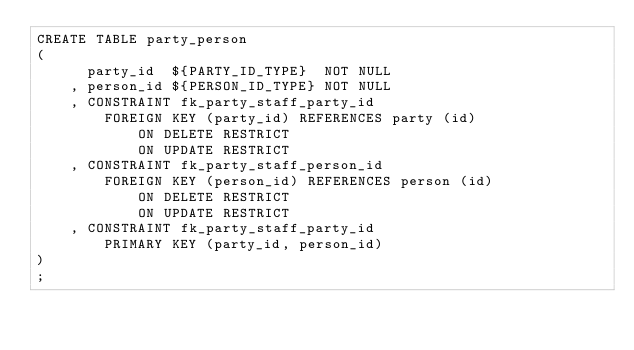Convert code to text. <code><loc_0><loc_0><loc_500><loc_500><_SQL_>CREATE TABLE party_person
(
      party_id  ${PARTY_ID_TYPE}  NOT NULL
    , person_id ${PERSON_ID_TYPE} NOT NULL
    , CONSTRAINT fk_party_staff_party_id
        FOREIGN KEY (party_id) REFERENCES party (id)
            ON DELETE RESTRICT
            ON UPDATE RESTRICT
    , CONSTRAINT fk_party_staff_person_id
        FOREIGN KEY (person_id) REFERENCES person (id)
            ON DELETE RESTRICT
            ON UPDATE RESTRICT
    , CONSTRAINT fk_party_staff_party_id
        PRIMARY KEY (party_id, person_id)
)
;
</code> 